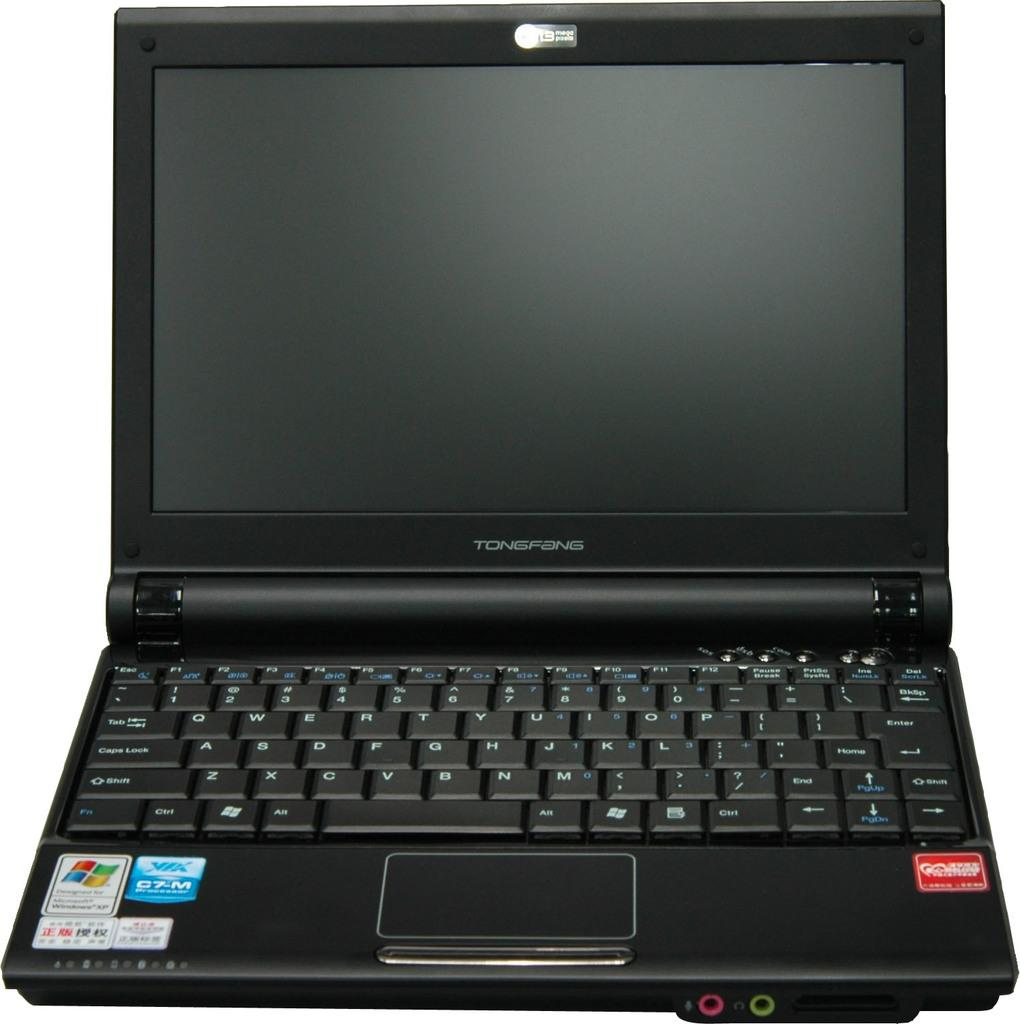<image>
Render a clear and concise summary of the photo. a laptop that says Tongfang on the front 